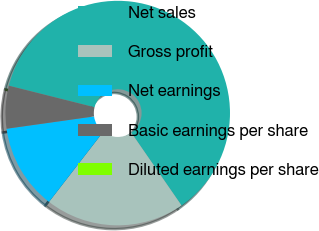Convert chart to OTSL. <chart><loc_0><loc_0><loc_500><loc_500><pie_chart><fcel>Net sales<fcel>Gross profit<fcel>Net earnings<fcel>Basic earnings per share<fcel>Diluted earnings per share<nl><fcel>61.46%<fcel>20.1%<fcel>12.29%<fcel>6.15%<fcel>0.0%<nl></chart> 